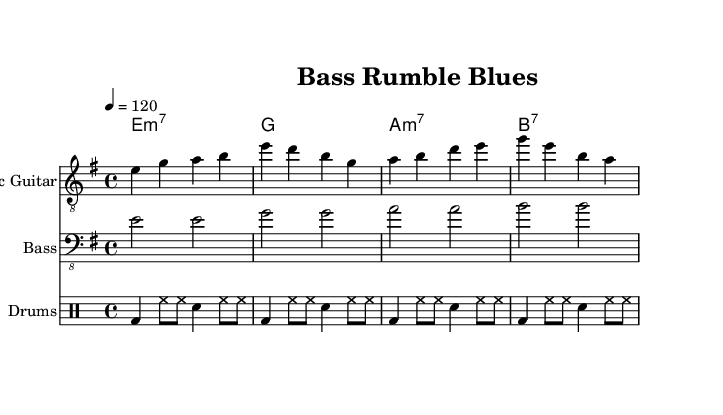What is the key signature of this music? The key signature is E minor, which is indicated by one sharp on the staff, specifically F#.
Answer: E minor What is the time signature of this music? The time signature is indicated at the beginning and shows four beats per measure, which is evident through the 4/4 notated at the start.
Answer: 4/4 What is the tempo marking? The tempo marking is set as a quarter note equals 120 BPM, which suggests a lively pace for the piece.
Answer: 120 How many bars are in the electric guitar part? The electric guitar part consists of four distinct measures or bars, which can be counted in the first section of the music.
Answer: 4 What type of chords are used in the synth section? The synth section consists of minor seventh and dominant seventh chords, which can be identified by the chord symbols notated above the staff.
Answer: Minor seventh and dominant seventh How does the bass line move in relation to the drums? The bass line alternates every two beats, which creates a solid foundation that complements the consistent rhythm of the drum pattern, enhancing the overall groove.
Answer: Alternates every two beats What is the rhythmic pattern of the drum section? The drum section predominantly features a kick drum on beats one and three, with hi-hats playing consistently, which creates a driving force in the music.
Answer: Kick on beats one and three 